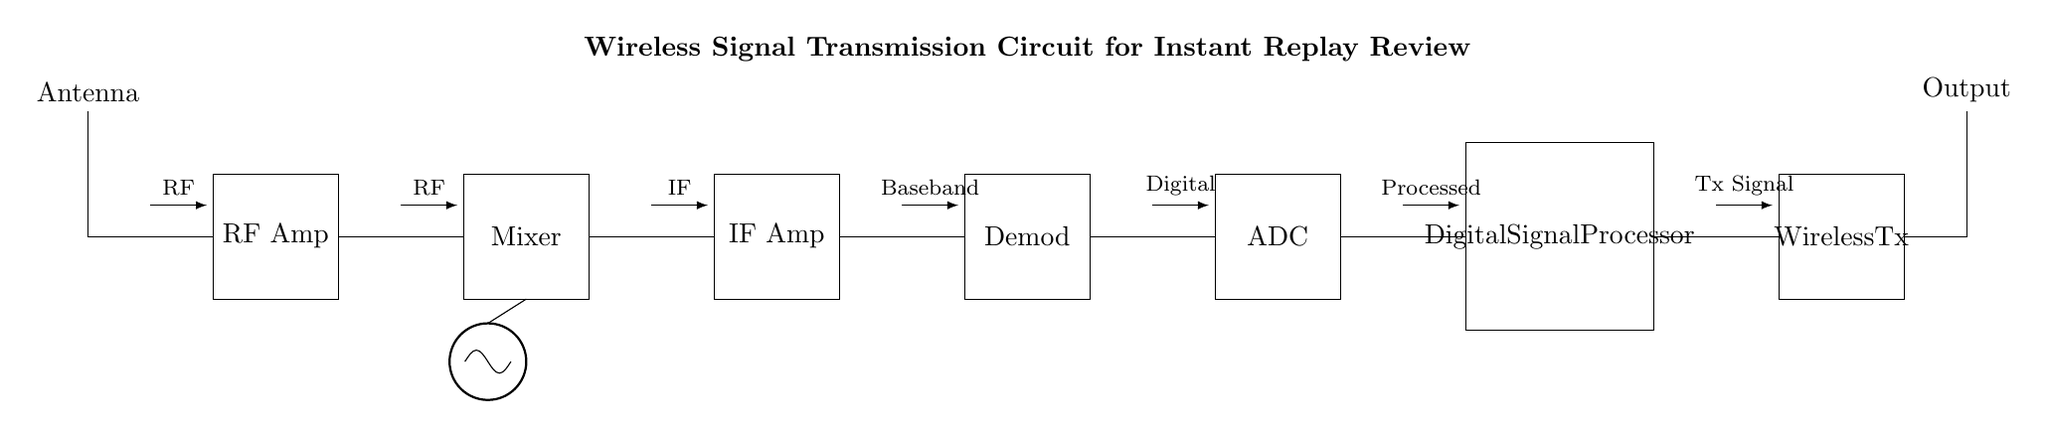What is the first component in the circuit? The first component is the antenna, which is depicted at the top left of the circuit diagram. It serves as the starting point for signal reception.
Answer: Antenna What type of amplifier is used? The circuit includes a radio frequency (RF) amplifier, which is used to boost the weak RF signals captured by the antenna, as indicated by the label in the diagram.
Answer: RF Amplifier What comes after the RF Amplifier in the signal flow? A mixer follows the RF amplifier; it combines the amplified RF signal with a local oscillator signal for further processing, as shown by the connection lines leading from the RF amplifier to the mixer.
Answer: Mixer How many main circuit components are there? There are seven main components in this wireless signal transmission circuit, which include the antenna, RF amplifier, mixer, local oscillator, IF amplifier, demodulator, ADC, digital signal processor, and wireless transmitter.
Answer: Seven What does the local oscillator signal do in the circuit? The local oscillator generates a frequency that mixes with the RF signal, which is critical for downconverting the RF signal to an intermediate frequency (IF) for easier processing, as illustrated by the connection to the mixer.
Answer: Downconversion Which component handles digital processing? The digital signal processor handles digital processing in the circuit; it takes the processed signal from the ADC and prepares it for transmission. This is indicated by its placement towards the end of the circuit diagram.
Answer: Digital Signal Processor 